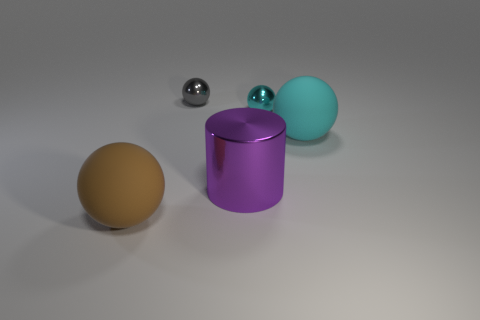The other sphere that is the same material as the gray sphere is what size?
Give a very brief answer. Small. There is a matte thing that is on the right side of the brown ball; is it the same shape as the small cyan shiny thing?
Offer a terse response. Yes. How many blue objects are either rubber spheres or metallic objects?
Your answer should be compact. 0. What number of other objects are the same shape as the cyan matte object?
Keep it short and to the point. 3. The thing that is in front of the tiny cyan thing and on the right side of the big purple metallic cylinder has what shape?
Your answer should be compact. Sphere. Are there any cyan spheres on the right side of the large cyan matte ball?
Provide a short and direct response. No. The brown thing that is the same shape as the tiny gray thing is what size?
Offer a very short reply. Large. Are there any other things that are the same size as the brown rubber object?
Provide a succinct answer. Yes. Is the shape of the cyan matte thing the same as the purple metallic thing?
Offer a very short reply. No. There is a matte thing that is in front of the large rubber ball right of the small gray ball; what size is it?
Provide a succinct answer. Large. 